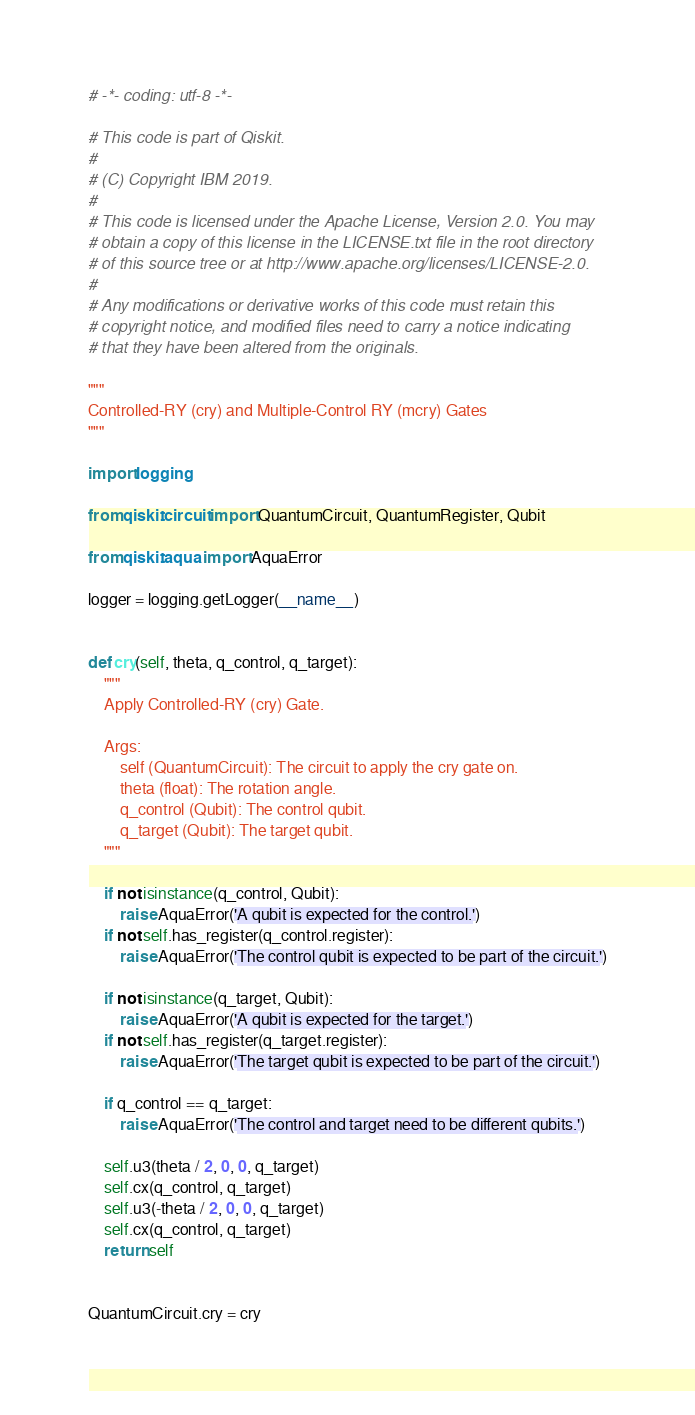Convert code to text. <code><loc_0><loc_0><loc_500><loc_500><_Python_># -*- coding: utf-8 -*-

# This code is part of Qiskit.
#
# (C) Copyright IBM 2019.
#
# This code is licensed under the Apache License, Version 2.0. You may
# obtain a copy of this license in the LICENSE.txt file in the root directory
# of this source tree or at http://www.apache.org/licenses/LICENSE-2.0.
#
# Any modifications or derivative works of this code must retain this
# copyright notice, and modified files need to carry a notice indicating
# that they have been altered from the originals.

"""
Controlled-RY (cry) and Multiple-Control RY (mcry) Gates
"""

import logging

from qiskit.circuit import QuantumCircuit, QuantumRegister, Qubit

from qiskit.aqua import AquaError

logger = logging.getLogger(__name__)


def cry(self, theta, q_control, q_target):
    """
    Apply Controlled-RY (cry) Gate.

    Args:
        self (QuantumCircuit): The circuit to apply the cry gate on.
        theta (float): The rotation angle.
        q_control (Qubit): The control qubit.
        q_target (Qubit): The target qubit.
    """

    if not isinstance(q_control, Qubit):
        raise AquaError('A qubit is expected for the control.')
    if not self.has_register(q_control.register):
        raise AquaError('The control qubit is expected to be part of the circuit.')

    if not isinstance(q_target, Qubit):
        raise AquaError('A qubit is expected for the target.')
    if not self.has_register(q_target.register):
        raise AquaError('The target qubit is expected to be part of the circuit.')

    if q_control == q_target:
        raise AquaError('The control and target need to be different qubits.')

    self.u3(theta / 2, 0, 0, q_target)
    self.cx(q_control, q_target)
    self.u3(-theta / 2, 0, 0, q_target)
    self.cx(q_control, q_target)
    return self


QuantumCircuit.cry = cry
</code> 